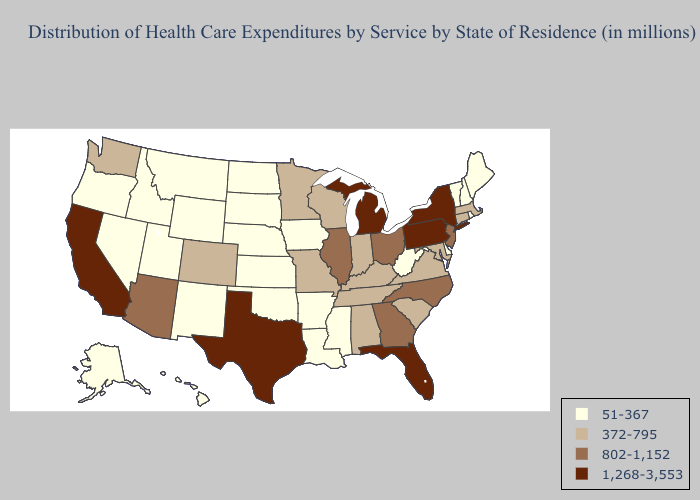What is the highest value in the USA?
Keep it brief. 1,268-3,553. Does Tennessee have the lowest value in the USA?
Concise answer only. No. What is the highest value in states that border Kentucky?
Answer briefly. 802-1,152. Name the states that have a value in the range 802-1,152?
Be succinct. Arizona, Georgia, Illinois, New Jersey, North Carolina, Ohio. Does the first symbol in the legend represent the smallest category?
Answer briefly. Yes. What is the value of Hawaii?
Write a very short answer. 51-367. What is the highest value in states that border Kansas?
Short answer required. 372-795. Is the legend a continuous bar?
Keep it brief. No. What is the highest value in states that border Virginia?
Write a very short answer. 802-1,152. What is the value of Massachusetts?
Answer briefly. 372-795. What is the lowest value in states that border Pennsylvania?
Quick response, please. 51-367. Does Delaware have a higher value than Oklahoma?
Be succinct. No. What is the highest value in the South ?
Keep it brief. 1,268-3,553. Which states have the lowest value in the USA?
Write a very short answer. Alaska, Arkansas, Delaware, Hawaii, Idaho, Iowa, Kansas, Louisiana, Maine, Mississippi, Montana, Nebraska, Nevada, New Hampshire, New Mexico, North Dakota, Oklahoma, Oregon, Rhode Island, South Dakota, Utah, Vermont, West Virginia, Wyoming. Does New Hampshire have the lowest value in the USA?
Write a very short answer. Yes. 